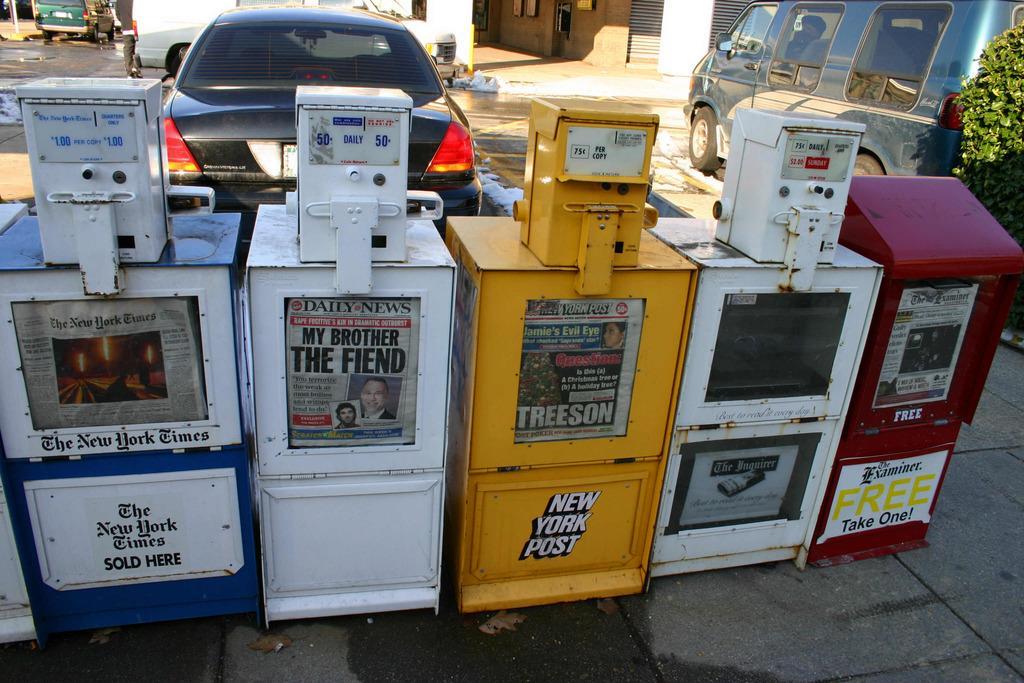Could you give a brief overview of what you see in this image? In this picture we can see vehicles,some objects on the ground. 